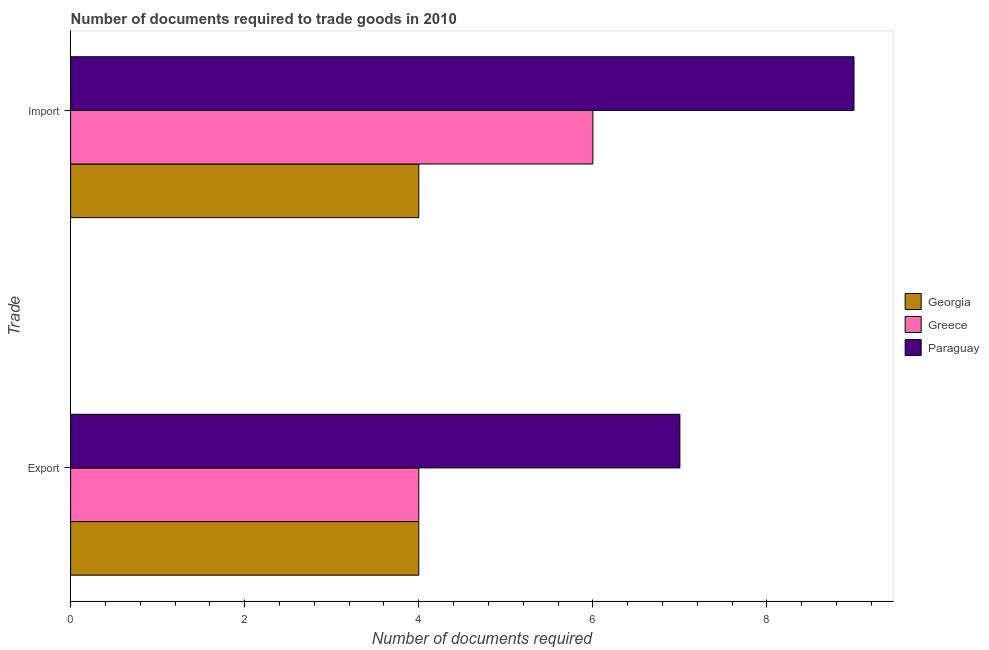How many groups of bars are there?
Your answer should be compact. 2. Are the number of bars on each tick of the Y-axis equal?
Ensure brevity in your answer.  Yes. How many bars are there on the 1st tick from the top?
Offer a very short reply. 3. How many bars are there on the 2nd tick from the bottom?
Give a very brief answer. 3. What is the label of the 2nd group of bars from the top?
Ensure brevity in your answer.  Export. What is the number of documents required to export goods in Greece?
Make the answer very short. 4. Across all countries, what is the maximum number of documents required to import goods?
Provide a short and direct response. 9. Across all countries, what is the minimum number of documents required to import goods?
Your response must be concise. 4. In which country was the number of documents required to import goods maximum?
Provide a succinct answer. Paraguay. In which country was the number of documents required to import goods minimum?
Ensure brevity in your answer.  Georgia. What is the total number of documents required to import goods in the graph?
Your response must be concise. 19. What is the difference between the number of documents required to export goods in Greece and that in Georgia?
Provide a short and direct response. 0. What is the difference between the number of documents required to export goods in Greece and the number of documents required to import goods in Paraguay?
Provide a succinct answer. -5. What is the difference between the number of documents required to export goods and number of documents required to import goods in Greece?
Make the answer very short. -2. What is the ratio of the number of documents required to import goods in Paraguay to that in Georgia?
Ensure brevity in your answer.  2.25. In how many countries, is the number of documents required to import goods greater than the average number of documents required to import goods taken over all countries?
Your answer should be compact. 1. What does the 3rd bar from the top in Export represents?
Offer a terse response. Georgia. What is the difference between two consecutive major ticks on the X-axis?
Your answer should be very brief. 2. Are the values on the major ticks of X-axis written in scientific E-notation?
Provide a short and direct response. No. Does the graph contain grids?
Keep it short and to the point. No. What is the title of the graph?
Ensure brevity in your answer.  Number of documents required to trade goods in 2010. What is the label or title of the X-axis?
Offer a terse response. Number of documents required. What is the label or title of the Y-axis?
Provide a short and direct response. Trade. What is the Number of documents required of Paraguay in Export?
Provide a short and direct response. 7. What is the Number of documents required in Georgia in Import?
Make the answer very short. 4. Across all Trade, what is the maximum Number of documents required in Greece?
Keep it short and to the point. 6. Across all Trade, what is the minimum Number of documents required in Georgia?
Offer a terse response. 4. What is the difference between the Number of documents required of Greece in Export and that in Import?
Make the answer very short. -2. What is the difference between the Number of documents required in Paraguay in Export and that in Import?
Your answer should be very brief. -2. What is the difference between the Number of documents required of Georgia in Export and the Number of documents required of Paraguay in Import?
Your answer should be compact. -5. What is the difference between the Number of documents required in Greece in Export and the Number of documents required in Paraguay in Import?
Offer a terse response. -5. What is the average Number of documents required of Paraguay per Trade?
Keep it short and to the point. 8. What is the difference between the Number of documents required in Greece and Number of documents required in Paraguay in Export?
Offer a very short reply. -3. What is the difference between the Number of documents required of Georgia and Number of documents required of Greece in Import?
Your answer should be compact. -2. What is the difference between the Number of documents required of Georgia and Number of documents required of Paraguay in Import?
Ensure brevity in your answer.  -5. What is the ratio of the Number of documents required in Georgia in Export to that in Import?
Keep it short and to the point. 1. What is the ratio of the Number of documents required in Greece in Export to that in Import?
Give a very brief answer. 0.67. What is the difference between the highest and the lowest Number of documents required in Greece?
Your answer should be compact. 2. What is the difference between the highest and the lowest Number of documents required of Paraguay?
Your answer should be very brief. 2. 